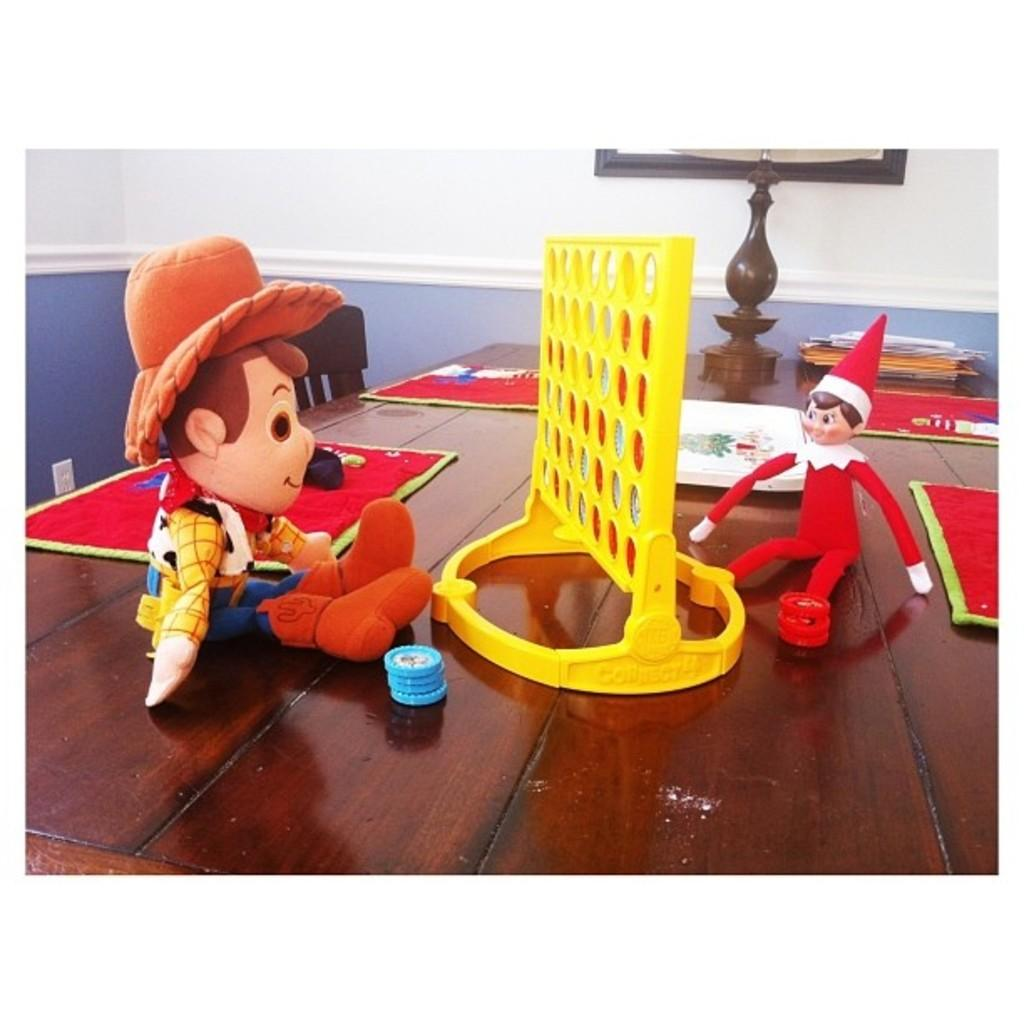What objects can be seen on the table in the image? There are toys, napkins, books, papers, and a tray on the table in the image. What might be used for cleaning or wiping in the image? Napkins are present on the table for cleaning or wiping. What type of items might be used for reading or writing in the image? Books and papers on the table might be used for reading or writing. What is located on the table that might be used for holding or serving items? There is a tray on the table that might be used for holding or serving items. What type of furniture is located beside the table in the image? There are chairs beside the table in the image. What type of hat can be seen on the table in the image? There is no hat present on the table in the image. What type of animal is depicted on the toys in the image? The provided facts do not mention any specific animals depicted on the toys in the image. 